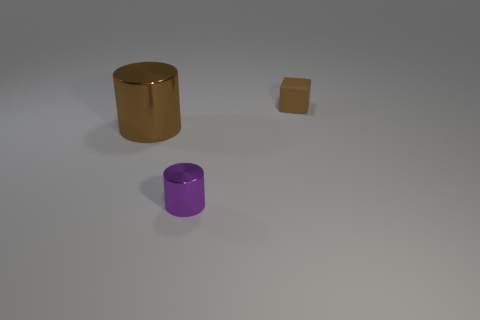Add 3 cubes. How many objects exist? 6 Subtract all cylinders. How many objects are left? 1 Subtract all big gray cylinders. Subtract all big cylinders. How many objects are left? 2 Add 1 brown cylinders. How many brown cylinders are left? 2 Add 3 small matte blocks. How many small matte blocks exist? 4 Subtract 0 red cylinders. How many objects are left? 3 